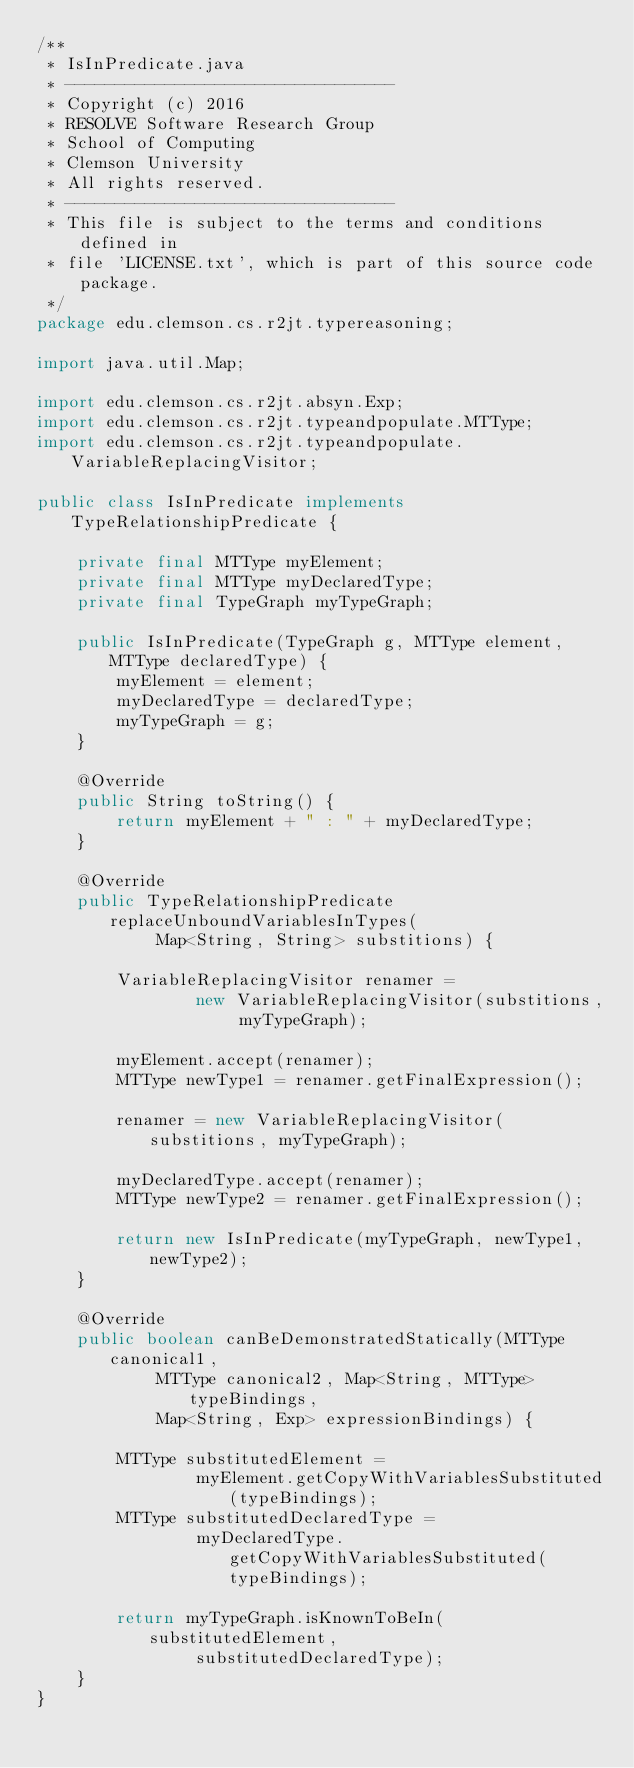<code> <loc_0><loc_0><loc_500><loc_500><_Java_>/**
 * IsInPredicate.java
 * ---------------------------------
 * Copyright (c) 2016
 * RESOLVE Software Research Group
 * School of Computing
 * Clemson University
 * All rights reserved.
 * ---------------------------------
 * This file is subject to the terms and conditions defined in
 * file 'LICENSE.txt', which is part of this source code package.
 */
package edu.clemson.cs.r2jt.typereasoning;

import java.util.Map;

import edu.clemson.cs.r2jt.absyn.Exp;
import edu.clemson.cs.r2jt.typeandpopulate.MTType;
import edu.clemson.cs.r2jt.typeandpopulate.VariableReplacingVisitor;

public class IsInPredicate implements TypeRelationshipPredicate {

    private final MTType myElement;
    private final MTType myDeclaredType;
    private final TypeGraph myTypeGraph;

    public IsInPredicate(TypeGraph g, MTType element, MTType declaredType) {
        myElement = element;
        myDeclaredType = declaredType;
        myTypeGraph = g;
    }

    @Override
    public String toString() {
        return myElement + " : " + myDeclaredType;
    }

    @Override
    public TypeRelationshipPredicate replaceUnboundVariablesInTypes(
            Map<String, String> substitions) {

        VariableReplacingVisitor renamer =
                new VariableReplacingVisitor(substitions, myTypeGraph);

        myElement.accept(renamer);
        MTType newType1 = renamer.getFinalExpression();

        renamer = new VariableReplacingVisitor(substitions, myTypeGraph);

        myDeclaredType.accept(renamer);
        MTType newType2 = renamer.getFinalExpression();

        return new IsInPredicate(myTypeGraph, newType1, newType2);
    }

    @Override
    public boolean canBeDemonstratedStatically(MTType canonical1,
            MTType canonical2, Map<String, MTType> typeBindings,
            Map<String, Exp> expressionBindings) {

        MTType substitutedElement =
                myElement.getCopyWithVariablesSubstituted(typeBindings);
        MTType substitutedDeclaredType =
                myDeclaredType.getCopyWithVariablesSubstituted(typeBindings);

        return myTypeGraph.isKnownToBeIn(substitutedElement,
                substitutedDeclaredType);
    }
}
</code> 